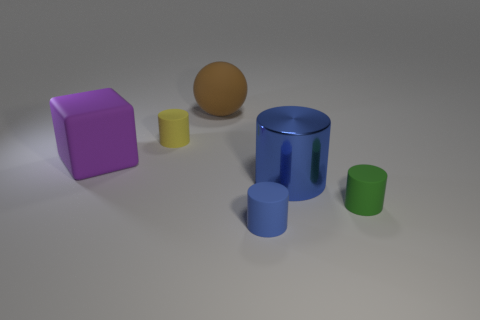There is another object that is the same color as the large metal thing; what is its shape?
Make the answer very short. Cylinder. There is a purple matte thing that is the same size as the metallic thing; what shape is it?
Keep it short and to the point. Cube. Is there a cylinder of the same color as the rubber block?
Your answer should be very brief. No. Are there an equal number of green things to the right of the big blue cylinder and yellow cylinders that are in front of the yellow thing?
Provide a short and direct response. No. There is a big blue object; is its shape the same as the big matte thing that is left of the large sphere?
Your answer should be very brief. No. How many other objects are there of the same material as the big brown sphere?
Offer a terse response. 4. There is a green rubber object; are there any metal cylinders in front of it?
Offer a very short reply. No. There is a yellow rubber thing; is its size the same as the blue thing in front of the tiny green rubber thing?
Your answer should be very brief. Yes. What is the color of the rubber block to the left of the big matte thing right of the big purple cube?
Keep it short and to the point. Purple. Do the blue metal cylinder and the purple rubber object have the same size?
Make the answer very short. Yes. 